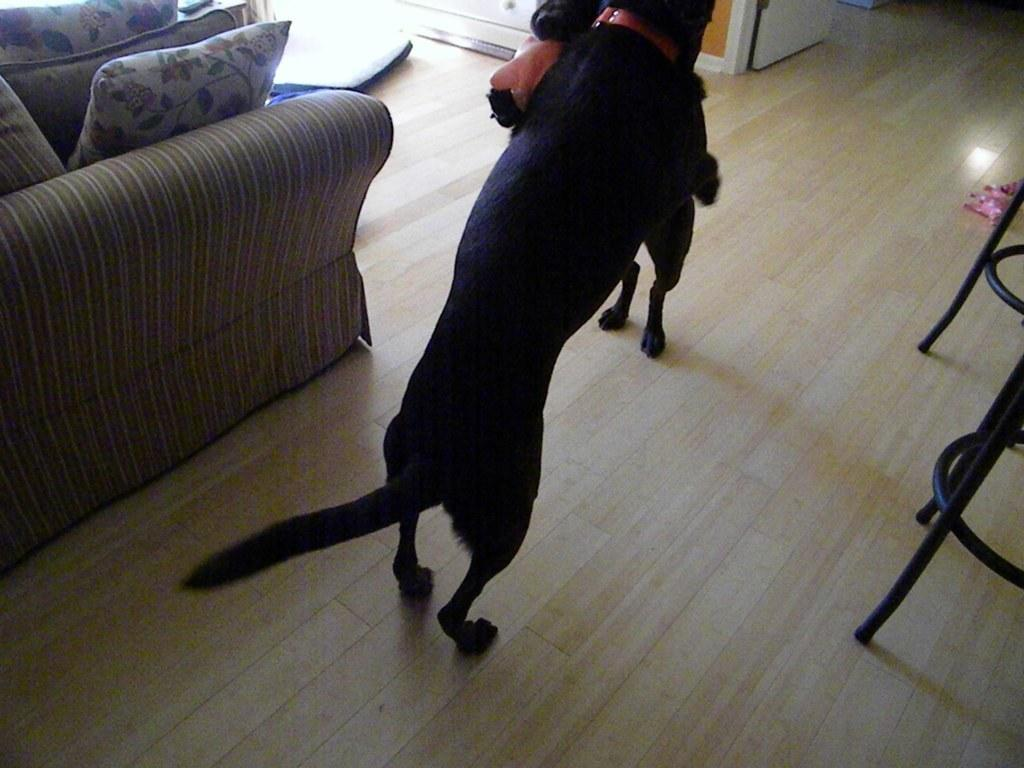What type of animals are present in the image? There are two black dogs in the image. What piece of furniture can be seen in the image? There is a sofa in the image. What are the cushions on the sofa used for? The cushions on the sofa are used for comfort and support. What type of division can be seen between the dogs in the image? There is no division between the dogs in the image; they are both present in the same space. 